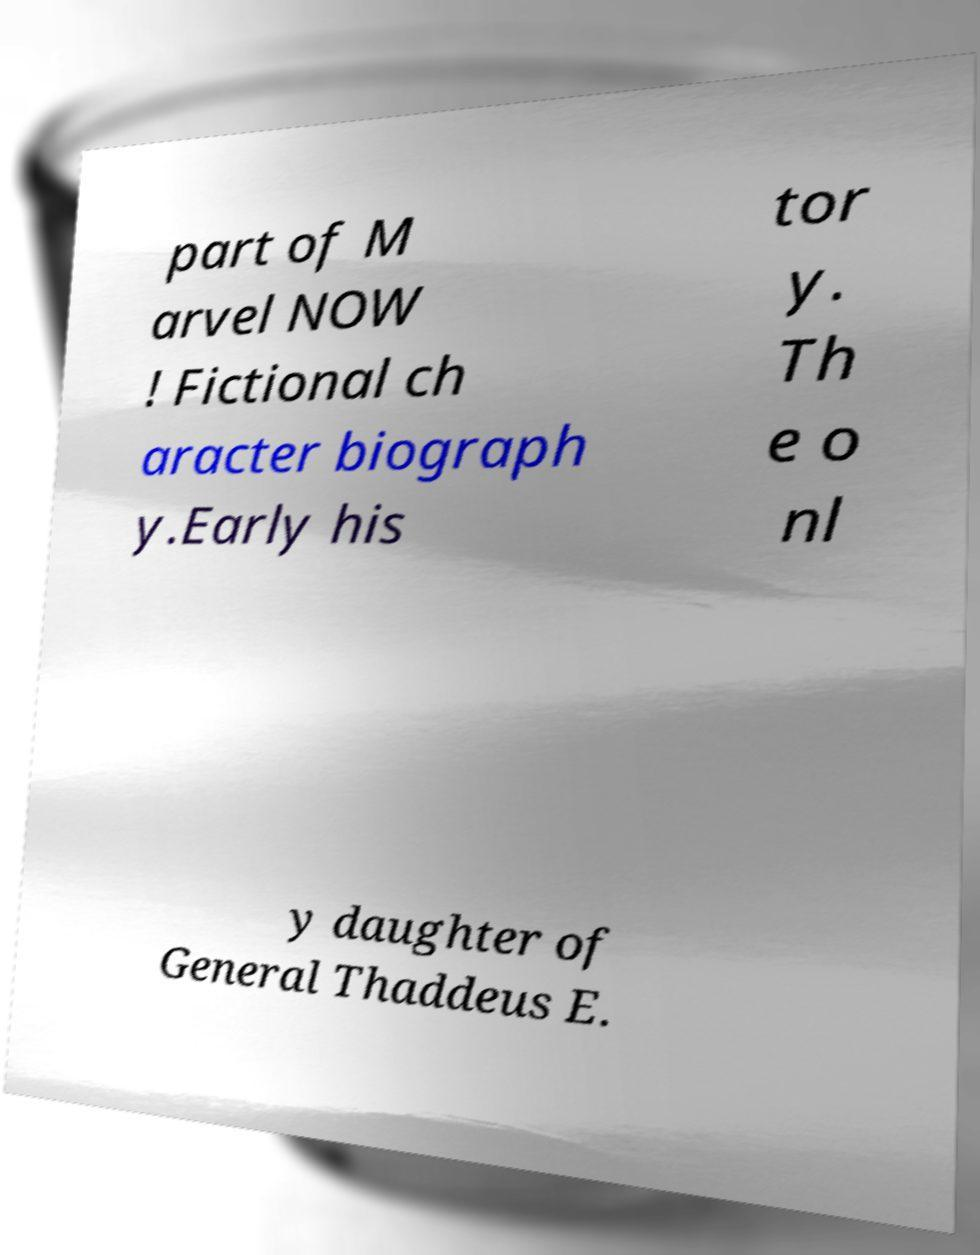For documentation purposes, I need the text within this image transcribed. Could you provide that? part of M arvel NOW ! Fictional ch aracter biograph y.Early his tor y. Th e o nl y daughter of General Thaddeus E. 